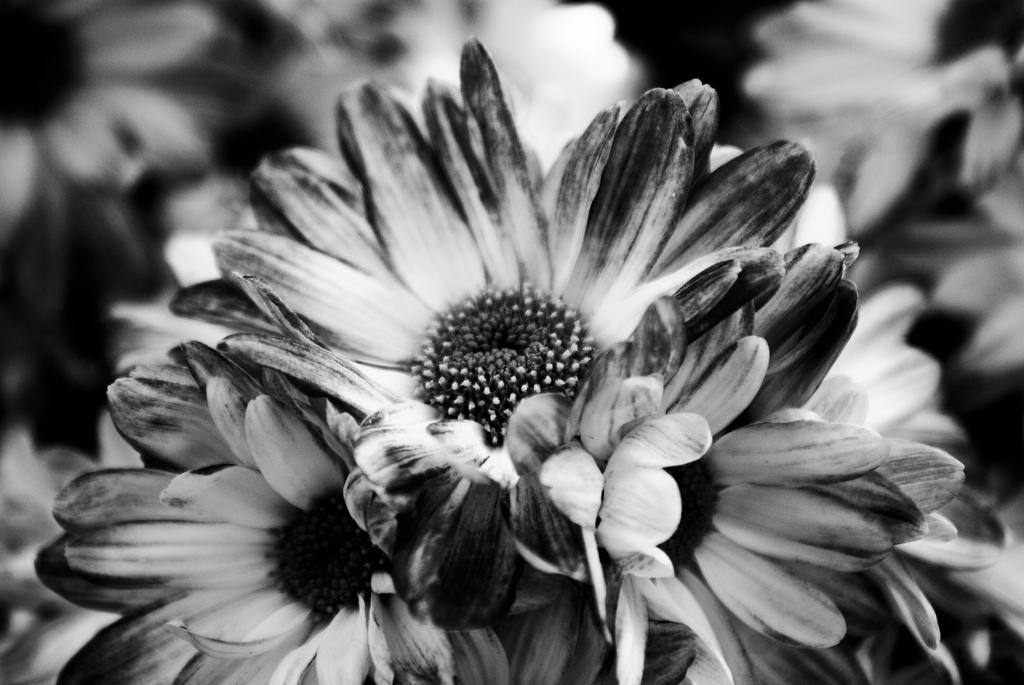What type of living organisms can be seen in the image? Flowers can be seen in the image. What type of hook can be seen attached to the cable in the image? There is no hook or cable present in the image; it only features flowers. 